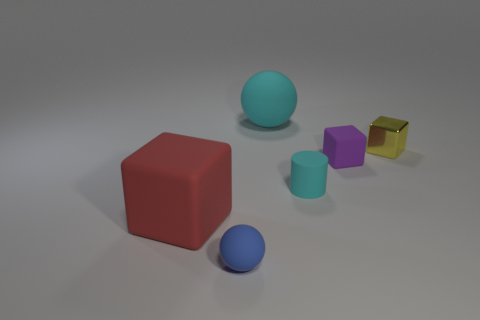Subtract all red cubes. How many cubes are left? 2 Subtract all cyan balls. How many balls are left? 1 Subtract all spheres. How many objects are left? 4 Subtract all red cylinders. How many red cubes are left? 1 Subtract all large shiny spheres. Subtract all metallic objects. How many objects are left? 5 Add 2 tiny metallic objects. How many tiny metallic objects are left? 3 Add 5 small green things. How many small green things exist? 5 Add 4 big cyan cubes. How many objects exist? 10 Subtract 1 yellow blocks. How many objects are left? 5 Subtract 1 balls. How many balls are left? 1 